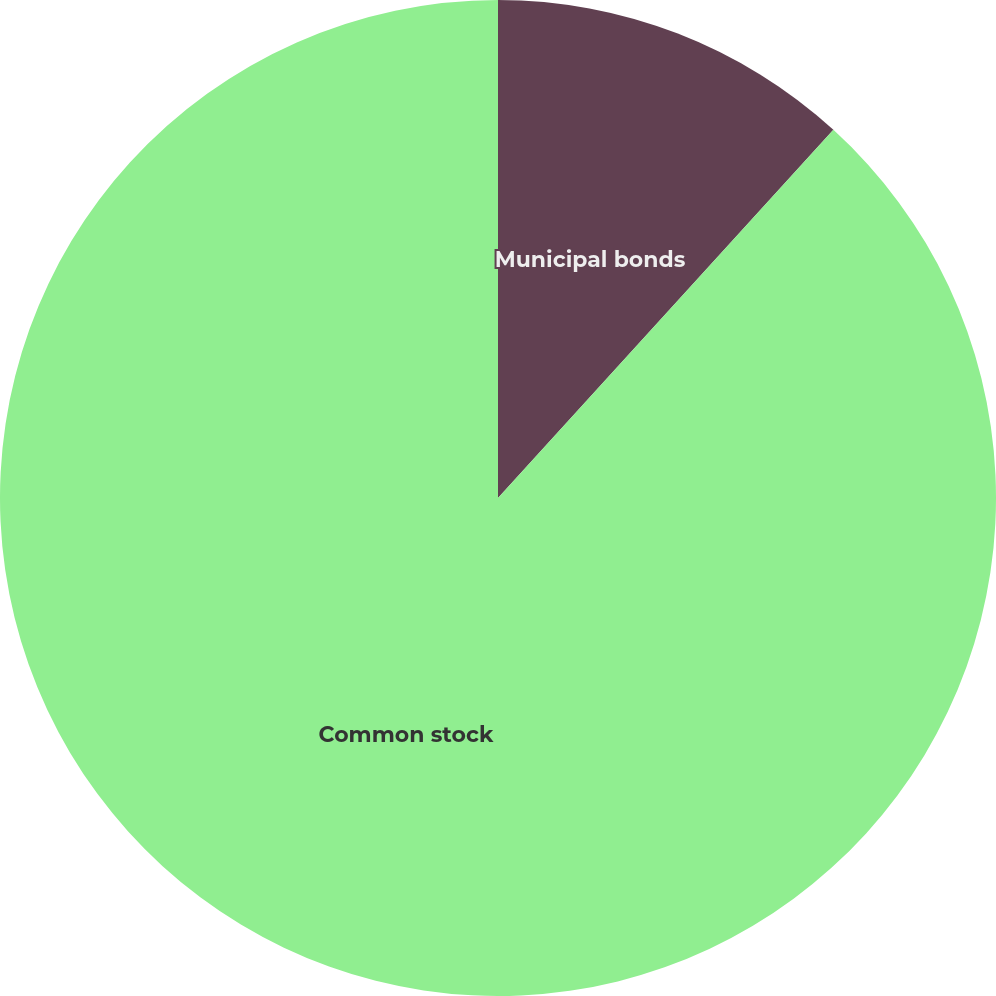Convert chart to OTSL. <chart><loc_0><loc_0><loc_500><loc_500><pie_chart><fcel>Municipal bonds<fcel>Common stock<nl><fcel>11.76%<fcel>88.24%<nl></chart> 